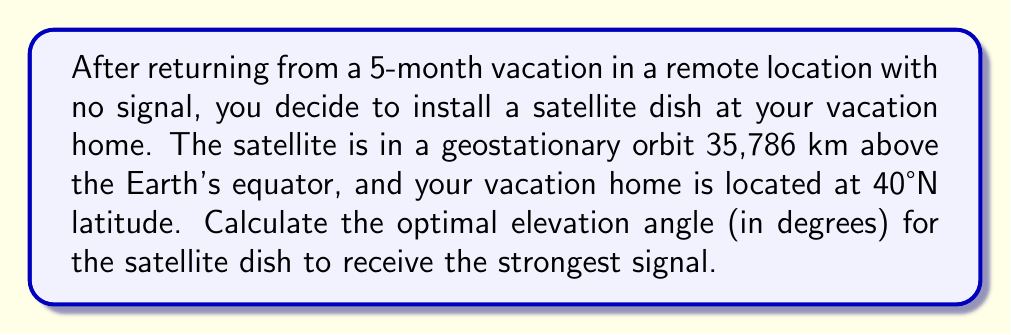Teach me how to tackle this problem. To solve this problem, we'll follow these steps:

1) First, we need to understand that the optimal angle for the satellite dish is perpendicular to the line of sight to the satellite.

2) We can model this situation as a right triangle, where:
   - The Earth's center is one vertex
   - Your location is another vertex
   - The satellite's position is the third vertex

3) Let's define our variables:
   $R$ = Earth's radius ≈ 6,371 km
   $h$ = Satellite's height above equator = 35,786 km
   $\phi$ = Your latitude = 40°

4) We need to find the angle between the horizontal plane at your location and the line to the satellite. Let's call this angle $\theta$.

5) Using the law of cosines in spherical trigonometry:

   $$\cos(90°+\theta) = \sin\phi \cdot \sin0° + \cos\phi \cdot \cos0° \cdot \cos\lambda$$

   where $\lambda$ is the difference in longitude between your location and the satellite's ground track.

6) Simplify:
   $$-\sin\theta = \cos\phi \cdot \cos\lambda$$

7) Solve for $\lambda$:
   $$\lambda = \arccos(-\frac{\sin\theta}{\cos\phi})$$

8) Now, in the plane containing the Earth's center, your location, and the satellite, we can use the law of sines:

   $$\frac{\sin(90°+\theta)}{R+h} = \frac{\sin\lambda}{R}$$

9) Simplify:
   $$\frac{\cos\theta}{R+h} = \frac{\sin\lambda}{R}$$

10) Substitute the expression for $\sin\lambda$ from step 7:
    $$\frac{\cos\theta}{R+h} = \frac{\sqrt{1-\sin^2\theta/\cos^2\phi}}{R}$$

11) Square both sides and solve for $\theta$ using a computer algebra system or numerical methods.

12) Using the given values, we get:
    $$\theta \approx 42.7°$$

This is the elevation angle from the horizon to the satellite. The optimal angle for the dish is perpendicular to this, so we need to subtract it from 90°:

$$90° - 42.7° = 47.3°$$
Answer: $47.3°$ 